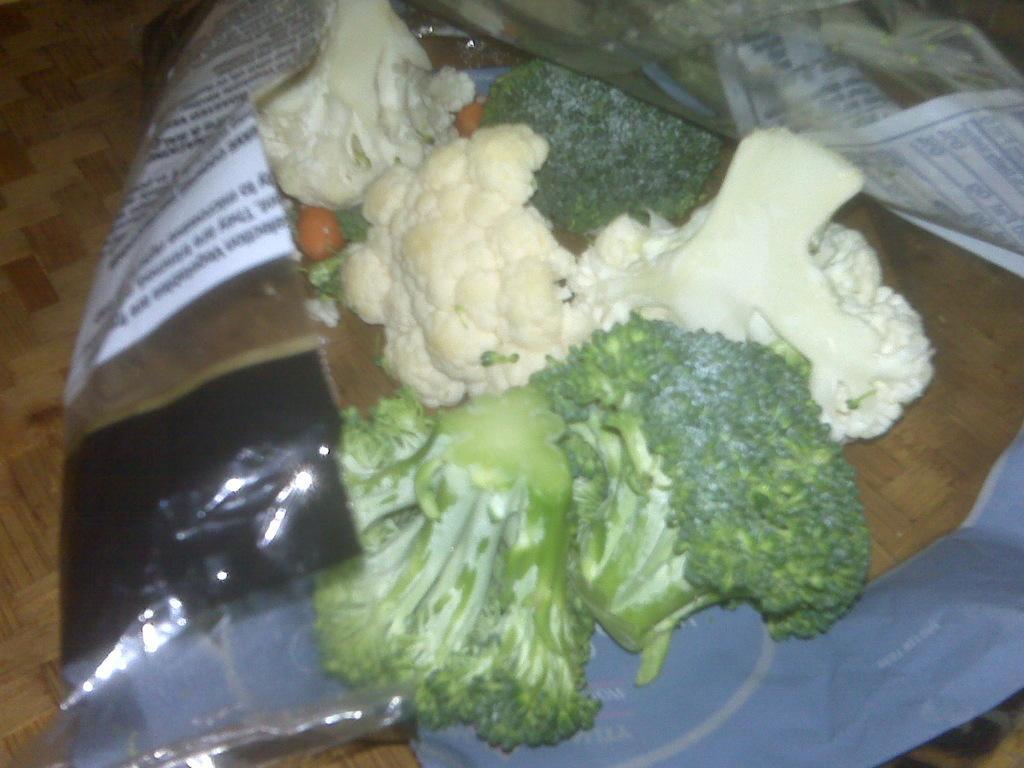How would you summarize this image in a sentence or two? In this image, I can see the chopped cauliflower and broccoli in a cover, which is placed on an object. 